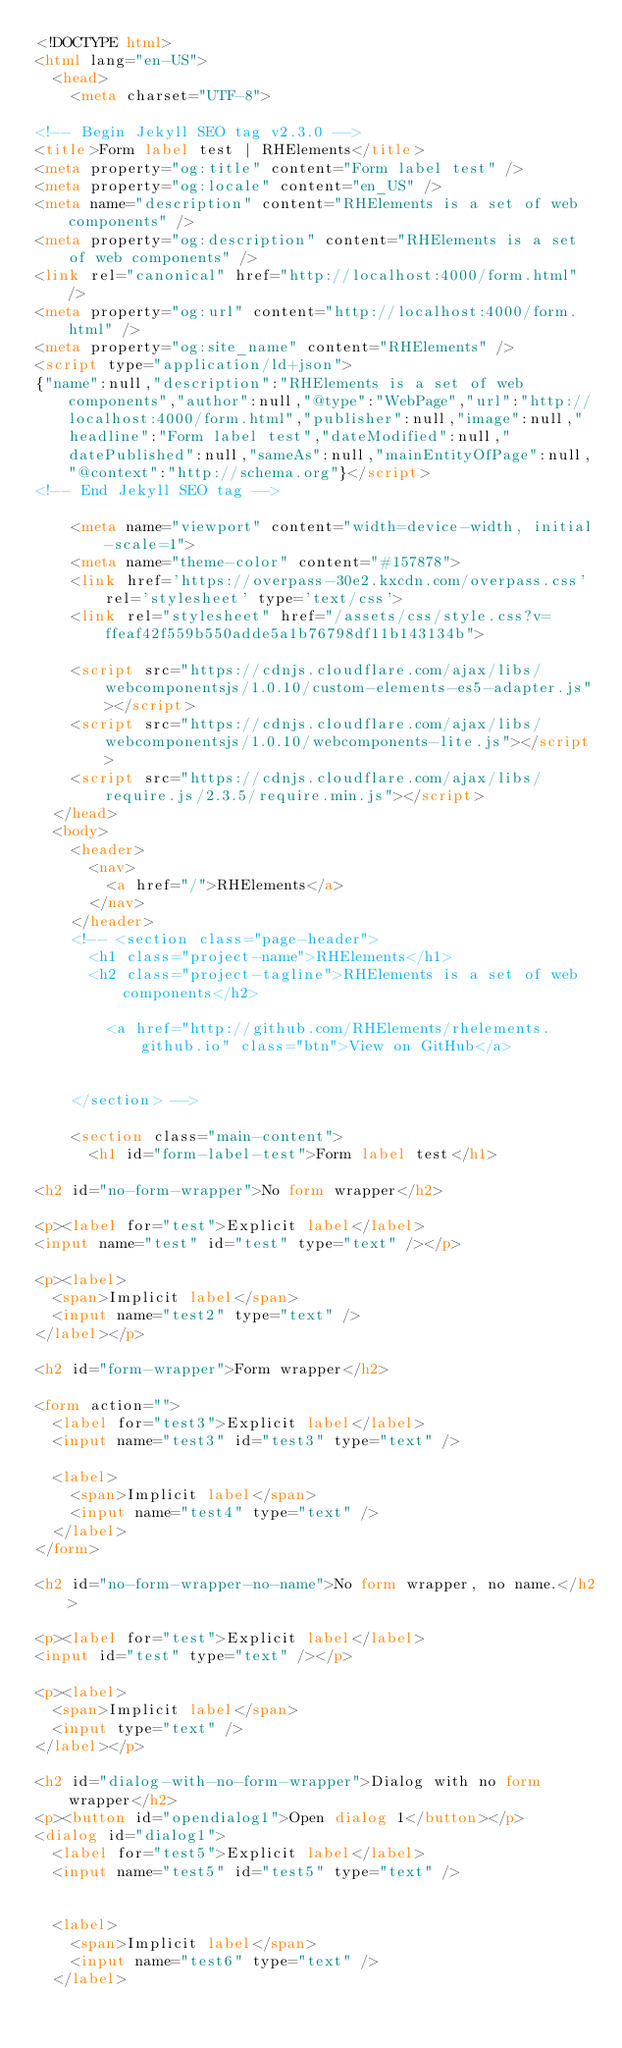<code> <loc_0><loc_0><loc_500><loc_500><_HTML_><!DOCTYPE html>
<html lang="en-US">
  <head>
    <meta charset="UTF-8">

<!-- Begin Jekyll SEO tag v2.3.0 -->
<title>Form label test | RHElements</title>
<meta property="og:title" content="Form label test" />
<meta property="og:locale" content="en_US" />
<meta name="description" content="RHElements is a set of web components" />
<meta property="og:description" content="RHElements is a set of web components" />
<link rel="canonical" href="http://localhost:4000/form.html" />
<meta property="og:url" content="http://localhost:4000/form.html" />
<meta property="og:site_name" content="RHElements" />
<script type="application/ld+json">
{"name":null,"description":"RHElements is a set of web components","author":null,"@type":"WebPage","url":"http://localhost:4000/form.html","publisher":null,"image":null,"headline":"Form label test","dateModified":null,"datePublished":null,"sameAs":null,"mainEntityOfPage":null,"@context":"http://schema.org"}</script>
<!-- End Jekyll SEO tag -->

    <meta name="viewport" content="width=device-width, initial-scale=1">
    <meta name="theme-color" content="#157878">
    <link href='https://overpass-30e2.kxcdn.com/overpass.css' rel='stylesheet' type='text/css'>
    <link rel="stylesheet" href="/assets/css/style.css?v=ffeaf42f559b550adde5a1b76798df11b143134b">

    <script src="https://cdnjs.cloudflare.com/ajax/libs/webcomponentsjs/1.0.10/custom-elements-es5-adapter.js"></script>
    <script src="https://cdnjs.cloudflare.com/ajax/libs/webcomponentsjs/1.0.10/webcomponents-lite.js"></script>
    <script src="https://cdnjs.cloudflare.com/ajax/libs/require.js/2.3.5/require.min.js"></script>
  </head>
  <body>
    <header>
      <nav>
        <a href="/">RHElements</a>
      </nav>
    </header>
    <!-- <section class="page-header">
      <h1 class="project-name">RHElements</h1>
      <h2 class="project-tagline">RHElements is a set of web components</h2>
      
        <a href="http://github.com/RHElements/rhelements.github.io" class="btn">View on GitHub</a>
      
      
    </section> -->

    <section class="main-content">
      <h1 id="form-label-test">Form label test</h1>

<h2 id="no-form-wrapper">No form wrapper</h2>

<p><label for="test">Explicit label</label>
<input name="test" id="test" type="text" /></p>

<p><label>
  <span>Implicit label</span>
  <input name="test2" type="text" />
</label></p>

<h2 id="form-wrapper">Form wrapper</h2>

<form action="">
  <label for="test3">Explicit label</label>
  <input name="test3" id="test3" type="text" />

  <label>
    <span>Implicit label</span>
    <input name="test4" type="text" />
  </label>
</form>

<h2 id="no-form-wrapper-no-name">No form wrapper, no name.</h2>

<p><label for="test">Explicit label</label>
<input id="test" type="text" /></p>

<p><label>
  <span>Implicit label</span>
  <input type="text" />
</label></p>

<h2 id="dialog-with-no-form-wrapper">Dialog with no form wrapper</h2>
<p><button id="opendialog1">Open dialog 1</button></p>
<dialog id="dialog1">
  <label for="test5">Explicit label</label>
  <input name="test5" id="test5" type="text" />


  <label>
    <span>Implicit label</span>
    <input name="test6" type="text" />
  </label></code> 